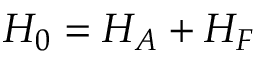<formula> <loc_0><loc_0><loc_500><loc_500>H _ { 0 } = H _ { A } + H _ { F }</formula> 